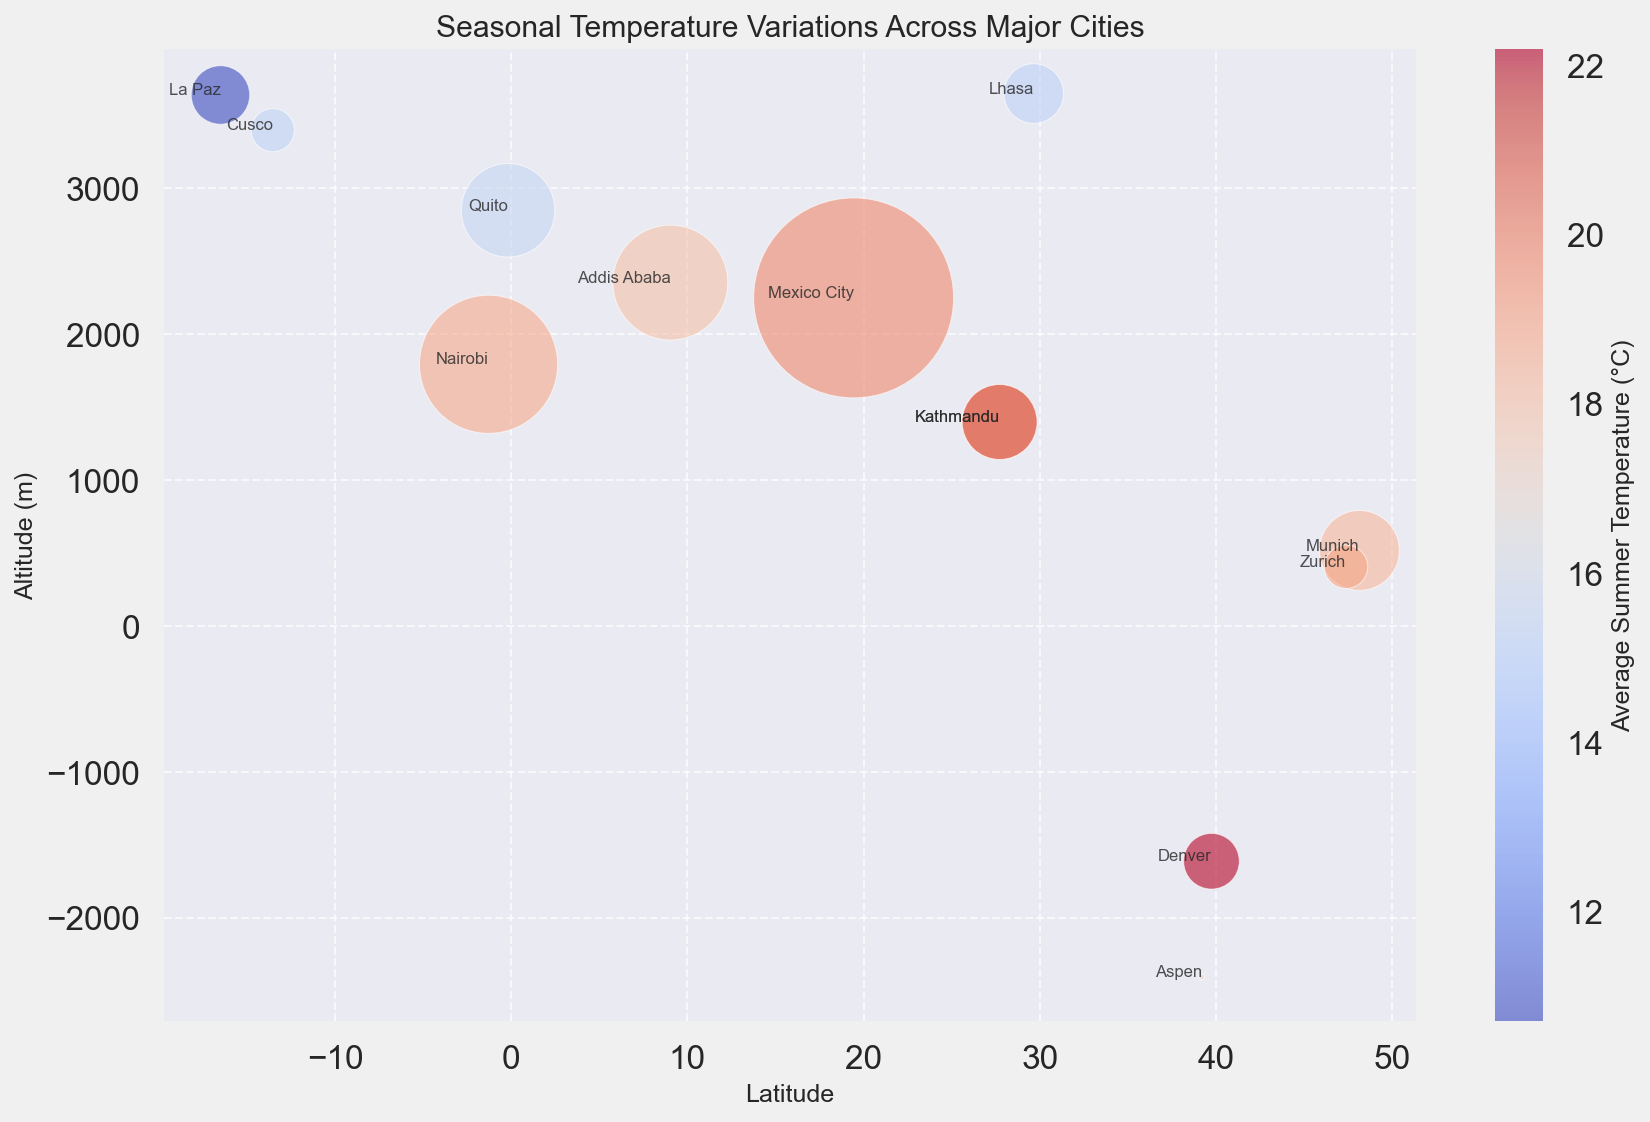Which city has the highest altitude? By observing the y-axis, the city with the highest position represents the highest altitude. The highest altitude is observed to be La Paz.
Answer: La Paz What is the average summer temperature of Zurich and Addis Ababa? To find the average, sum the average summer temperatures of Zurich (19.0) and Addis Ababa (18.0), then divide by 2. The calculation is (19.0 + 18.0) / 2 = 18.5
Answer: 18.5 Which city located at a similar latitude to Nairobi has a higher altitude? By comparing the latitudes close to -1.2864, Quito (-0.1807) is similar. Observing the y-axis for altitude, Quito (2850m) is higher than Nairobi (1795m).
Answer: Quito Which city has the smallest bubble size? The bubble size represents the population, and the smallest bubble on the chart corresponds to Aspen.
Answer: Aspen Which city shows the greatest difference between average winter and summer temperatures? To find the difference, we calculate for each city: e.g., Denver (22.2 - (-1.0) = 23.2), Mexico City (19.8 - 14.0 = 5.8), etc. The greatest difference is observed for Denver.
Answer: Denver What is the latitude and altitude combination that corresponds to the city with the highest average summer temperature? By observing the color intensity, the brightest red bubble corresponds to Mexico City. It has a latitude of 19.4326 and an altitude of 2250m.
Answer: 19.4326, 2250m Which city has an altitude nearly 2000m higher than Nairobi? Adding 2000m to Nairobi's altitude (1795m + 2000m = 3795m), La Paz (3640m) or Lhasa (3650m) is the closest match.
Answer: Lhasa Do cities with lower latitudes generally have higher average winter temperatures? By observing cities with lower latitudes (closer to 0), such as Mexico City, Nairobi, Quito, and Addis Ababa, we notice they have higher average winter temperatures compared to cities like Munich, Zurich, and Aspen.
Answer: Yes 